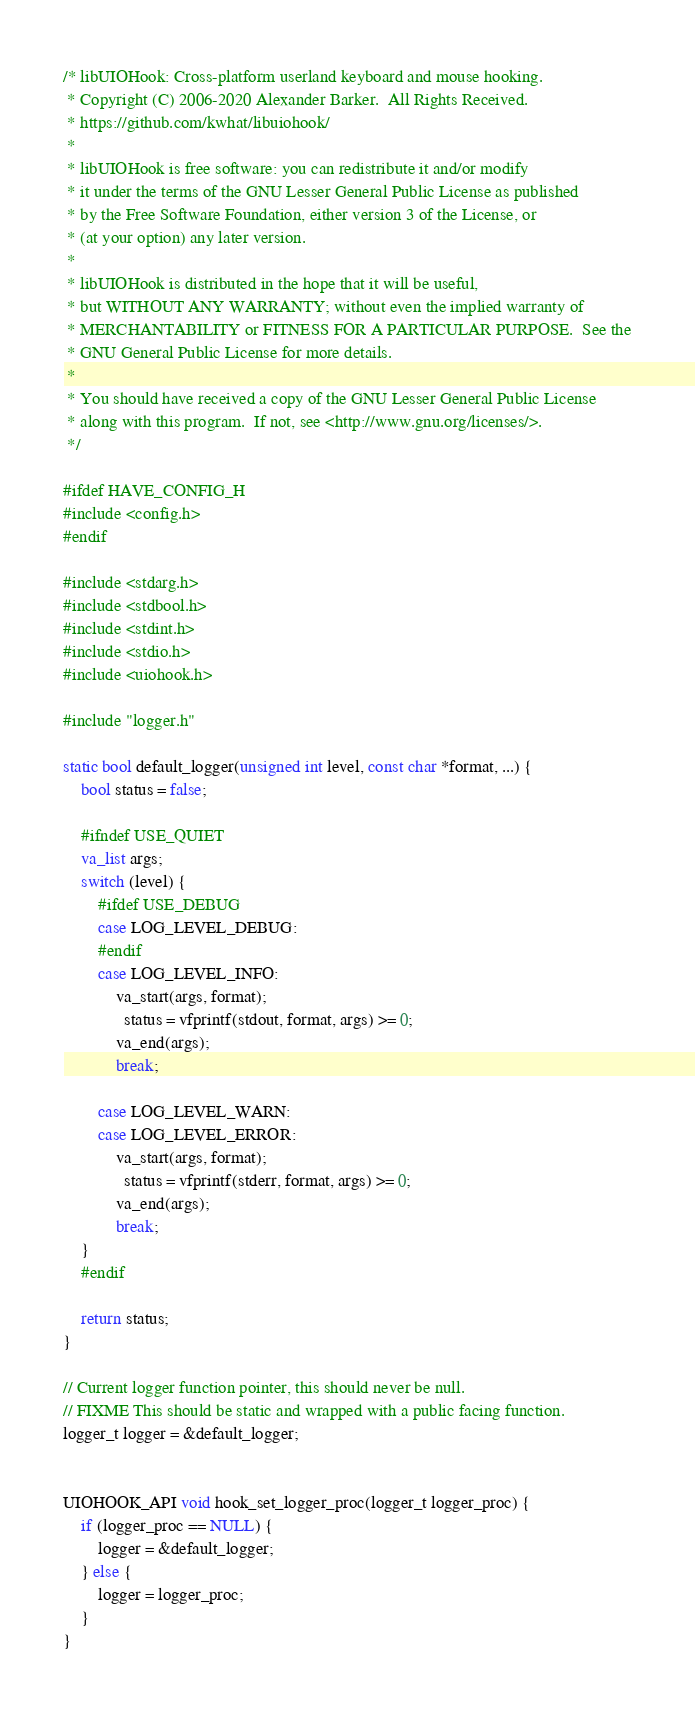Convert code to text. <code><loc_0><loc_0><loc_500><loc_500><_C_>/* libUIOHook: Cross-platform userland keyboard and mouse hooking.
 * Copyright (C) 2006-2020 Alexander Barker.  All Rights Received.
 * https://github.com/kwhat/libuiohook/
 *
 * libUIOHook is free software: you can redistribute it and/or modify
 * it under the terms of the GNU Lesser General Public License as published
 * by the Free Software Foundation, either version 3 of the License, or
 * (at your option) any later version.
 *
 * libUIOHook is distributed in the hope that it will be useful,
 * but WITHOUT ANY WARRANTY; without even the implied warranty of
 * MERCHANTABILITY or FITNESS FOR A PARTICULAR PURPOSE.  See the
 * GNU General Public License for more details.
 *
 * You should have received a copy of the GNU Lesser General Public License
 * along with this program.  If not, see <http://www.gnu.org/licenses/>.
 */

#ifdef HAVE_CONFIG_H
#include <config.h>
#endif

#include <stdarg.h>
#include <stdbool.h>
#include <stdint.h>
#include <stdio.h>
#include <uiohook.h>

#include "logger.h"

static bool default_logger(unsigned int level, const char *format, ...) {
    bool status = false;

    #ifndef USE_QUIET
    va_list args;
    switch (level) {
        #ifdef USE_DEBUG
        case LOG_LEVEL_DEBUG:
        #endif
        case LOG_LEVEL_INFO:
            va_start(args, format);
              status = vfprintf(stdout, format, args) >= 0;
            va_end(args);
            break;

        case LOG_LEVEL_WARN:
        case LOG_LEVEL_ERROR:
            va_start(args, format);
              status = vfprintf(stderr, format, args) >= 0;
            va_end(args);
            break;
    }
    #endif

    return status;
}

// Current logger function pointer, this should never be null.
// FIXME This should be static and wrapped with a public facing function.
logger_t logger = &default_logger;


UIOHOOK_API void hook_set_logger_proc(logger_t logger_proc) {
    if (logger_proc == NULL) {
        logger = &default_logger;
    } else {
        logger = logger_proc;
    }
}
</code> 